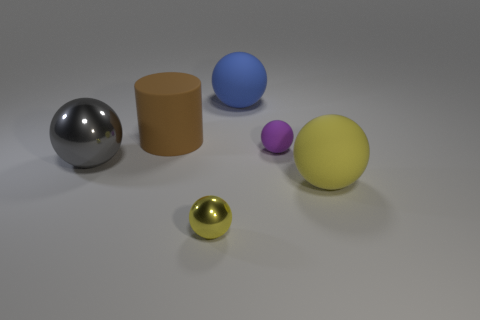Subtract all gray blocks. How many yellow balls are left? 2 Subtract all yellow balls. How many balls are left? 3 Subtract 3 spheres. How many spheres are left? 2 Subtract all big yellow spheres. How many spheres are left? 4 Add 1 tiny red matte objects. How many objects exist? 7 Subtract all gray balls. Subtract all brown cubes. How many balls are left? 4 Subtract all cylinders. How many objects are left? 5 Subtract all small blue rubber cylinders. Subtract all large shiny objects. How many objects are left? 5 Add 2 gray metallic objects. How many gray metallic objects are left? 3 Add 4 big green metallic objects. How many big green metallic objects exist? 4 